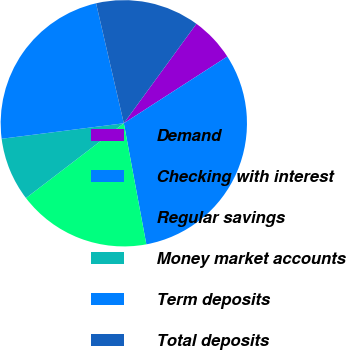<chart> <loc_0><loc_0><loc_500><loc_500><pie_chart><fcel>Demand<fcel>Checking with interest<fcel>Regular savings<fcel>Money market accounts<fcel>Term deposits<fcel>Total deposits<nl><fcel>5.85%<fcel>31.19%<fcel>17.54%<fcel>8.38%<fcel>23.39%<fcel>13.65%<nl></chart> 